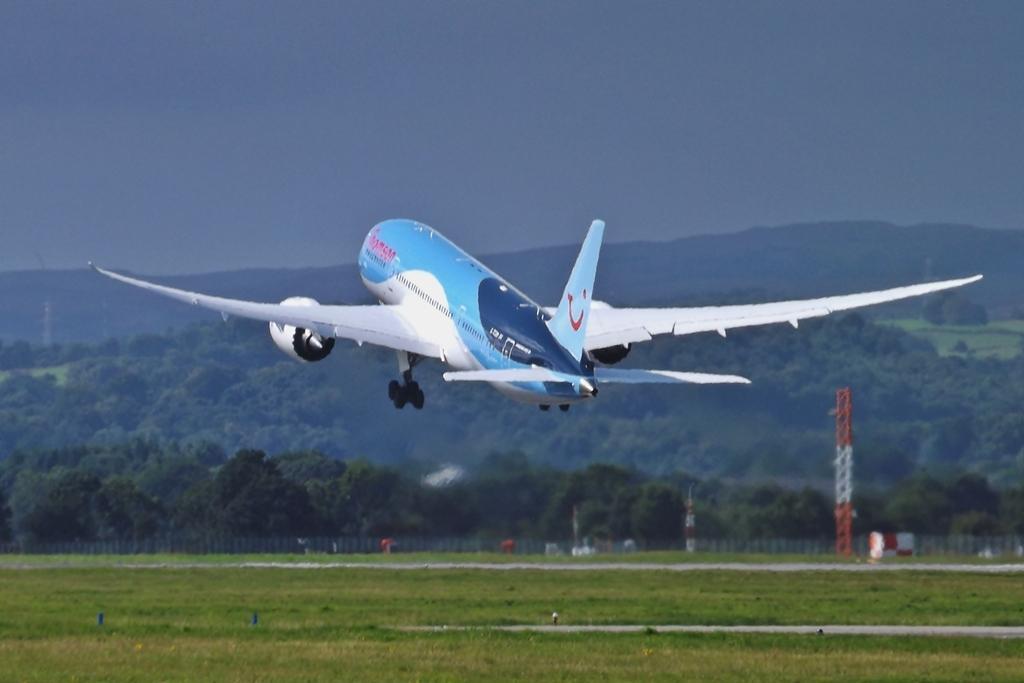Describe this image in one or two sentences. In this image we can see a flight flying. On the ground there is grass. In the back we can see towers. Also there are trees, hill and sky. 